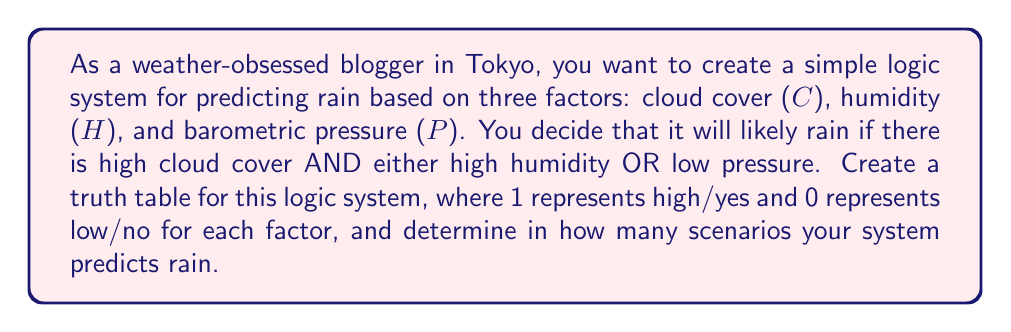Teach me how to tackle this problem. To solve this problem, we need to create a truth table based on the given logic. Let's break it down step by step:

1) First, we need to translate the given logic into a boolean expression:

   Rain = C AND (H OR NOT P)

2) Now, let's create the truth table. We'll have three input variables (C, H, P) and one output (Rain). There will be $2^3 = 8$ possible combinations of inputs.

3) Let's fill in the table:

   $$\begin{array}{|c|c|c|c|c|c|c|}
   \hline
   C & H & P & \text{NOT P} & \text{H OR NOT P} & \text{Rain} \\
   \hline
   0 & 0 & 0 & 1 & 1 & 0 \\
   0 & 0 & 1 & 0 & 0 & 0 \\
   0 & 1 & 0 & 1 & 1 & 0 \\
   0 & 1 & 1 & 0 & 1 & 0 \\
   1 & 0 & 0 & 1 & 1 & 1 \\
   1 & 0 & 1 & 0 & 0 & 0 \\
   1 & 1 & 0 & 1 & 1 & 1 \\
   1 & 1 & 1 & 0 & 1 & 1 \\
   \hline
   \end{array}$$

4) To determine the final "Rain" column:
   - If C is 0, Rain is always 0 regardless of H and P.
   - If C is 1, Rain is 1 when (H OR NOT P) is 1.

5) Count the number of 1's in the Rain column to determine in how many scenarios the system predicts rain.
Answer: The truth table shows that the system predicts rain in 3 out of 8 possible scenarios. 